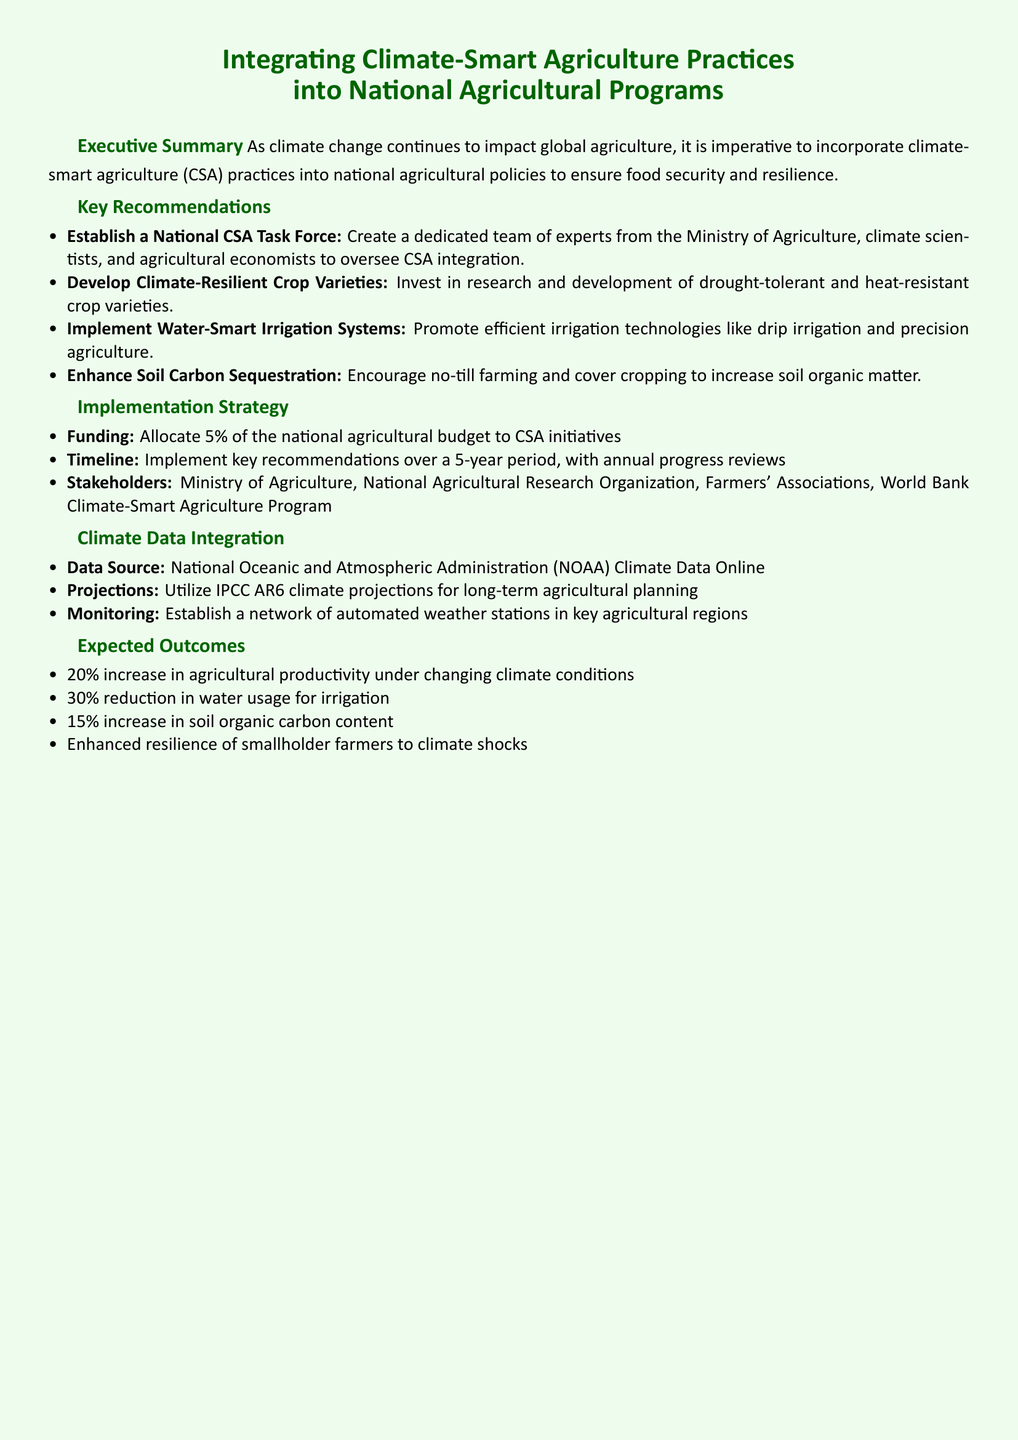What is the main focus of the document? The main focus is on incorporating climate-smart agriculture practices into national agricultural policies.
Answer: Climate-smart agriculture How much of the national agricultural budget should be allocated to CSA initiatives? The document specifies that 5% of the national agricultural budget should be allocated.
Answer: 5% What is one of the expected outcomes related to soil carbon content? The document indicates a 15% increase in soil organic carbon content as an expected outcome.
Answer: 15% Who should be included as stakeholders in the implementation strategy? The stakeholders include the Ministry of Agriculture, National Agricultural Research Organization, and Farmers' Associations.
Answer: Ministry of Agriculture What type of irrigation systems does the recommendation promote? The document recommends implementing water-smart irrigation systems.
Answer: Water-smart irrigation systems What is the timeline for implementing key recommendations? The document states that the timeline for implementation is over a 5-year period.
Answer: 5 years What is one of the key recommendations for enhancing soil health? Encouraging no-till farming and cover cropping is recommended to enhance soil health.
Answer: No-till farming and cover cropping Which organization’s climate data is suggested as a source? The document suggests utilizing data from the National Oceanic and Atmospheric Administration (NOAA).
Answer: National Oceanic and Atmospheric Administration What is the purpose of establishing a National CSA Task Force? The purpose is to oversee CSA integration with experts from various relevant fields.
Answer: Oversee CSA integration 